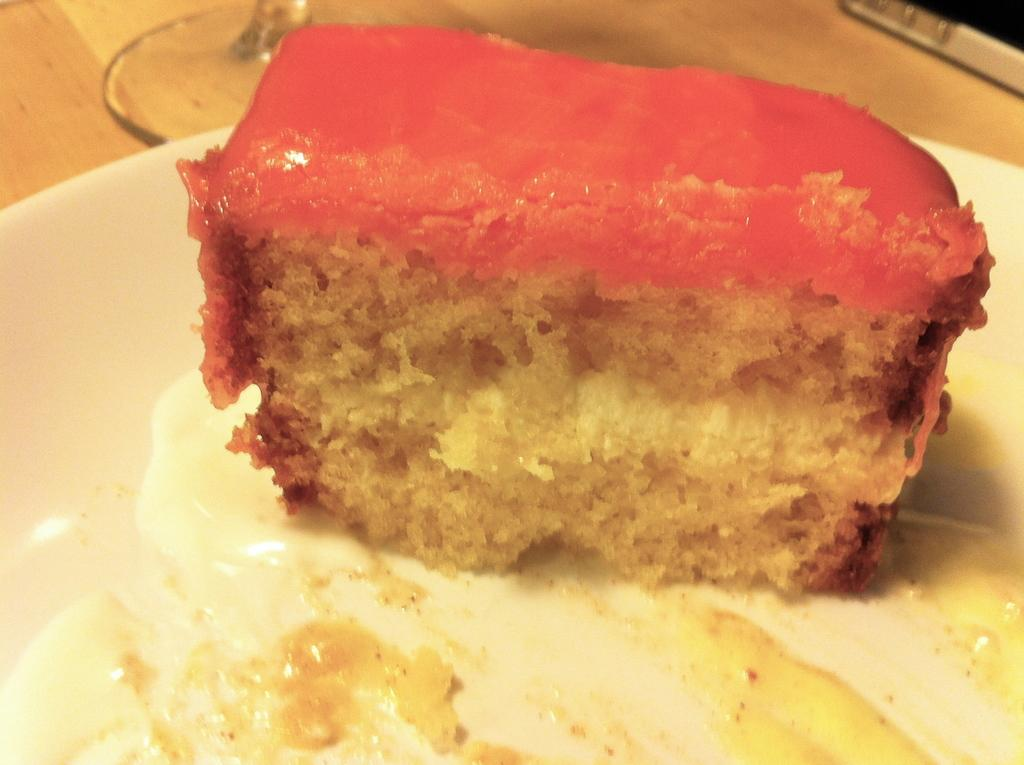What type of food is visible on a plate in the image? There is a slice of pastry on a plate in the image. What else can be seen on the table in the image? There is a glass on the table in the image. What historical event is depicted in the image? There is no historical event depicted in the image; it features a slice of pastry on a plate and a glass on a table. 